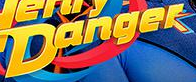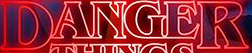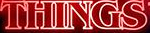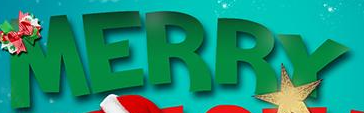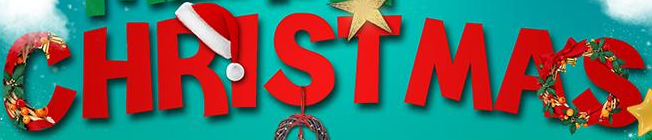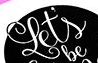Read the text from these images in sequence, separated by a semicolon. Danger; DANGER; THINGS; MERRY; CHRISTMAS; Let's 